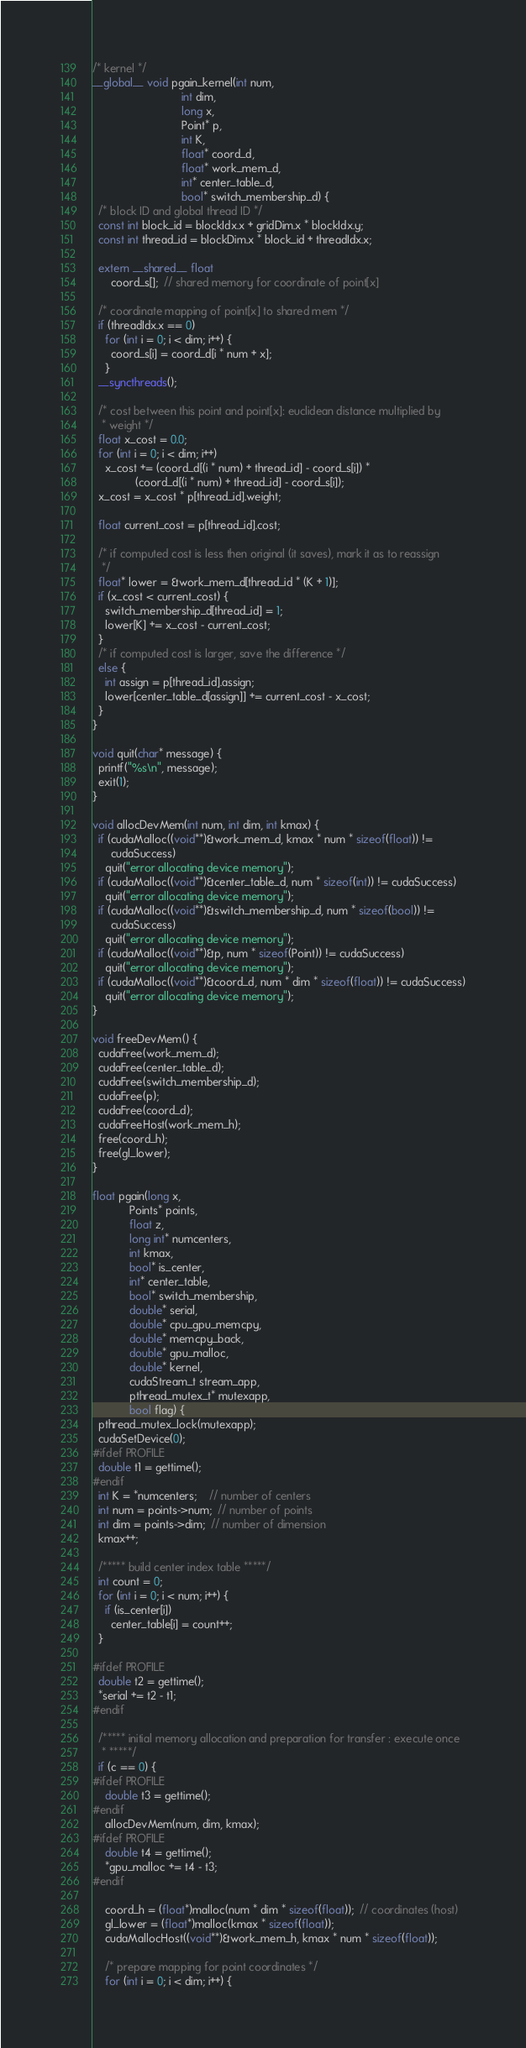Convert code to text. <code><loc_0><loc_0><loc_500><loc_500><_Cuda_>/* kernel */
__global__ void pgain_kernel(int num,
                             int dim,
                             long x,
                             Point* p,
                             int K,
                             float* coord_d,
                             float* work_mem_d,
                             int* center_table_d,
                             bool* switch_membership_d) {
  /* block ID and global thread ID */
  const int block_id = blockIdx.x + gridDim.x * blockIdx.y;
  const int thread_id = blockDim.x * block_id + threadIdx.x;

  extern __shared__ float
      coord_s[];  // shared memory for coordinate of point[x]

  /* coordinate mapping of point[x] to shared mem */
  if (threadIdx.x == 0)
    for (int i = 0; i < dim; i++) {
      coord_s[i] = coord_d[i * num + x];
    }
  __syncthreads();

  /* cost between this point and point[x]: euclidean distance multiplied by
   * weight */
  float x_cost = 0.0;
  for (int i = 0; i < dim; i++)
    x_cost += (coord_d[(i * num) + thread_id] - coord_s[i]) *
              (coord_d[(i * num) + thread_id] - coord_s[i]);
  x_cost = x_cost * p[thread_id].weight;

  float current_cost = p[thread_id].cost;

  /* if computed cost is less then original (it saves), mark it as to reassign
   */
  float* lower = &work_mem_d[thread_id * (K + 1)];
  if (x_cost < current_cost) {
    switch_membership_d[thread_id] = 1;
    lower[K] += x_cost - current_cost;
  }
  /* if computed cost is larger, save the difference */
  else {
    int assign = p[thread_id].assign;
    lower[center_table_d[assign]] += current_cost - x_cost;
  }
}

void quit(char* message) {
  printf("%s\n", message);
  exit(1);
}

void allocDevMem(int num, int dim, int kmax) {
  if (cudaMalloc((void**)&work_mem_d, kmax * num * sizeof(float)) !=
      cudaSuccess)
    quit("error allocating device memory");
  if (cudaMalloc((void**)&center_table_d, num * sizeof(int)) != cudaSuccess)
    quit("error allocating device memory");
  if (cudaMalloc((void**)&switch_membership_d, num * sizeof(bool)) !=
      cudaSuccess)
    quit("error allocating device memory");
  if (cudaMalloc((void**)&p, num * sizeof(Point)) != cudaSuccess)
    quit("error allocating device memory");
  if (cudaMalloc((void**)&coord_d, num * dim * sizeof(float)) != cudaSuccess)
    quit("error allocating device memory");
}

void freeDevMem() {
  cudaFree(work_mem_d);
  cudaFree(center_table_d);
  cudaFree(switch_membership_d);
  cudaFree(p);
  cudaFree(coord_d);
  cudaFreeHost(work_mem_h);
  free(coord_h);
  free(gl_lower);
}

float pgain(long x,
            Points* points,
            float z,
            long int* numcenters,
            int kmax,
            bool* is_center,
            int* center_table,
            bool* switch_membership,
            double* serial,
            double* cpu_gpu_memcpy,
            double* memcpy_back,
            double* gpu_malloc,
            double* kernel,
            cudaStream_t stream_app,
            pthread_mutex_t* mutexapp,
            bool flag) {
  pthread_mutex_lock(mutexapp);
  cudaSetDevice(0);
#ifdef PROFILE
  double t1 = gettime();
#endif
  int K = *numcenters;    // number of centers
  int num = points->num;  // number of points
  int dim = points->dim;  // number of dimension
  kmax++;

  /***** build center index table *****/
  int count = 0;
  for (int i = 0; i < num; i++) {
    if (is_center[i])
      center_table[i] = count++;
  }

#ifdef PROFILE
  double t2 = gettime();
  *serial += t2 - t1;
#endif

  /***** initial memory allocation and preparation for transfer : execute once
   * *****/
  if (c == 0) {
#ifdef PROFILE
    double t3 = gettime();
#endif
    allocDevMem(num, dim, kmax);
#ifdef PROFILE
    double t4 = gettime();
    *gpu_malloc += t4 - t3;
#endif

    coord_h = (float*)malloc(num * dim * sizeof(float));  // coordinates (host)
    gl_lower = (float*)malloc(kmax * sizeof(float));
    cudaMallocHost((void**)&work_mem_h, kmax * num * sizeof(float));

    /* prepare mapping for point coordinates */
    for (int i = 0; i < dim; i++) {</code> 